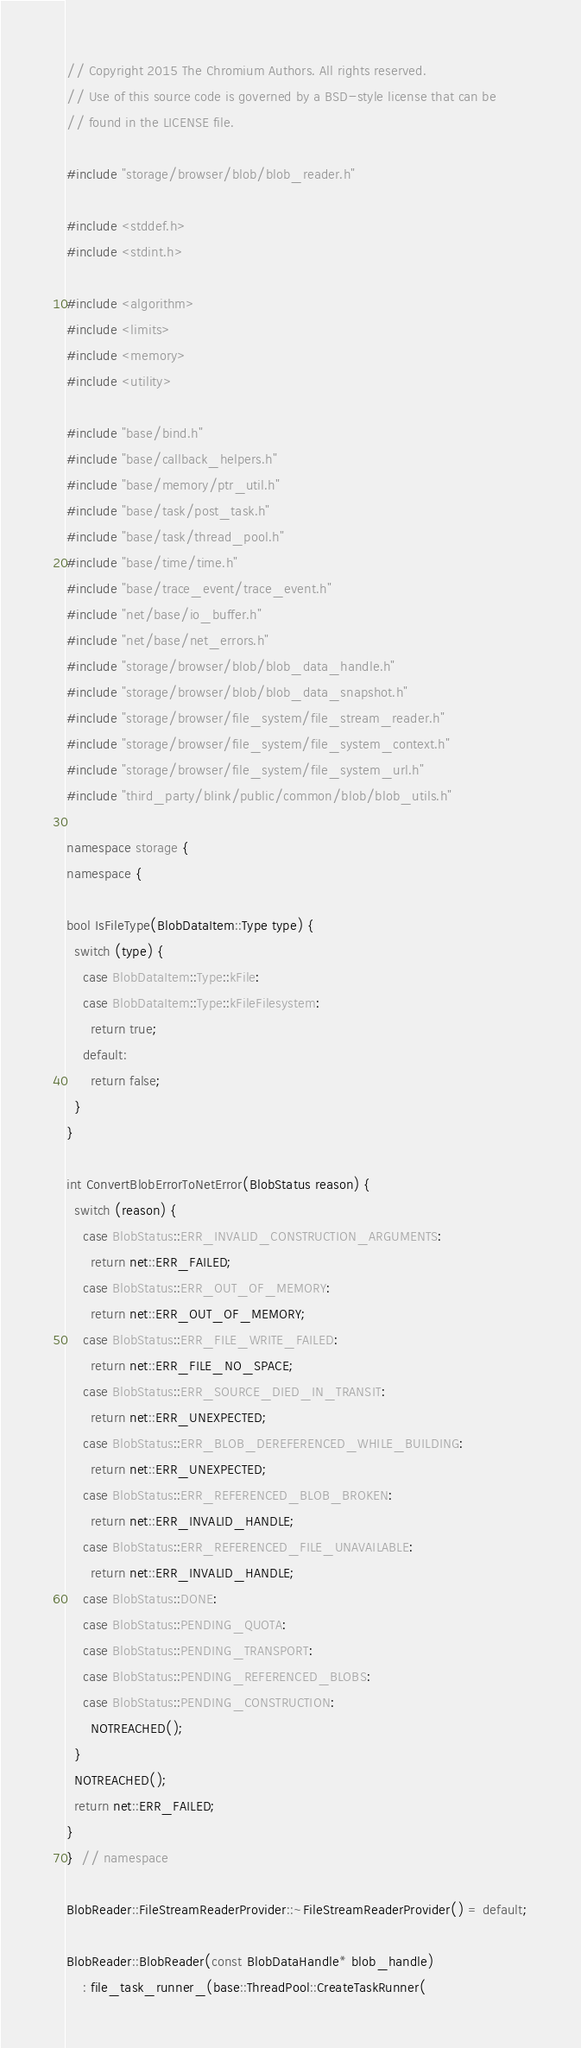Convert code to text. <code><loc_0><loc_0><loc_500><loc_500><_C++_>// Copyright 2015 The Chromium Authors. All rights reserved.
// Use of this source code is governed by a BSD-style license that can be
// found in the LICENSE file.

#include "storage/browser/blob/blob_reader.h"

#include <stddef.h>
#include <stdint.h>

#include <algorithm>
#include <limits>
#include <memory>
#include <utility>

#include "base/bind.h"
#include "base/callback_helpers.h"
#include "base/memory/ptr_util.h"
#include "base/task/post_task.h"
#include "base/task/thread_pool.h"
#include "base/time/time.h"
#include "base/trace_event/trace_event.h"
#include "net/base/io_buffer.h"
#include "net/base/net_errors.h"
#include "storage/browser/blob/blob_data_handle.h"
#include "storage/browser/blob/blob_data_snapshot.h"
#include "storage/browser/file_system/file_stream_reader.h"
#include "storage/browser/file_system/file_system_context.h"
#include "storage/browser/file_system/file_system_url.h"
#include "third_party/blink/public/common/blob/blob_utils.h"

namespace storage {
namespace {

bool IsFileType(BlobDataItem::Type type) {
  switch (type) {
    case BlobDataItem::Type::kFile:
    case BlobDataItem::Type::kFileFilesystem:
      return true;
    default:
      return false;
  }
}

int ConvertBlobErrorToNetError(BlobStatus reason) {
  switch (reason) {
    case BlobStatus::ERR_INVALID_CONSTRUCTION_ARGUMENTS:
      return net::ERR_FAILED;
    case BlobStatus::ERR_OUT_OF_MEMORY:
      return net::ERR_OUT_OF_MEMORY;
    case BlobStatus::ERR_FILE_WRITE_FAILED:
      return net::ERR_FILE_NO_SPACE;
    case BlobStatus::ERR_SOURCE_DIED_IN_TRANSIT:
      return net::ERR_UNEXPECTED;
    case BlobStatus::ERR_BLOB_DEREFERENCED_WHILE_BUILDING:
      return net::ERR_UNEXPECTED;
    case BlobStatus::ERR_REFERENCED_BLOB_BROKEN:
      return net::ERR_INVALID_HANDLE;
    case BlobStatus::ERR_REFERENCED_FILE_UNAVAILABLE:
      return net::ERR_INVALID_HANDLE;
    case BlobStatus::DONE:
    case BlobStatus::PENDING_QUOTA:
    case BlobStatus::PENDING_TRANSPORT:
    case BlobStatus::PENDING_REFERENCED_BLOBS:
    case BlobStatus::PENDING_CONSTRUCTION:
      NOTREACHED();
  }
  NOTREACHED();
  return net::ERR_FAILED;
}
}  // namespace

BlobReader::FileStreamReaderProvider::~FileStreamReaderProvider() = default;

BlobReader::BlobReader(const BlobDataHandle* blob_handle)
    : file_task_runner_(base::ThreadPool::CreateTaskRunner(</code> 